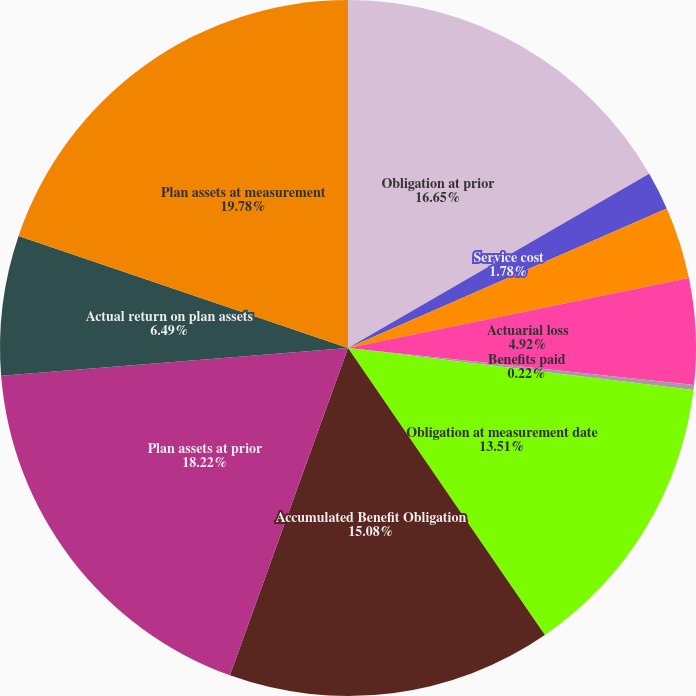Convert chart to OTSL. <chart><loc_0><loc_0><loc_500><loc_500><pie_chart><fcel>Obligation at prior<fcel>Service cost<fcel>Interest cost<fcel>Actuarial loss<fcel>Benefits paid<fcel>Obligation at measurement date<fcel>Accumulated Benefit Obligation<fcel>Plan assets at prior<fcel>Actual return on plan assets<fcel>Plan assets at measurement<nl><fcel>16.65%<fcel>1.78%<fcel>3.35%<fcel>4.92%<fcel>0.22%<fcel>13.51%<fcel>15.08%<fcel>18.22%<fcel>6.49%<fcel>19.78%<nl></chart> 